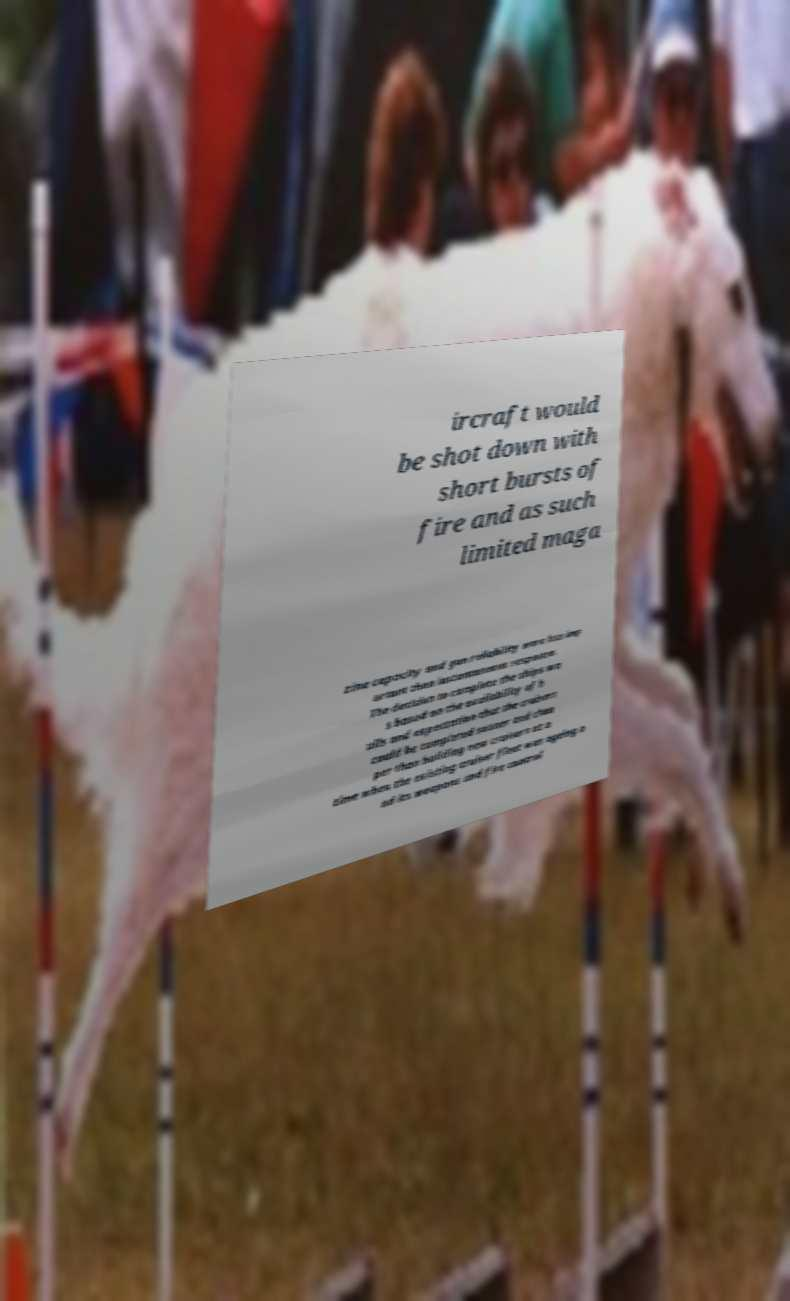For documentation purposes, I need the text within this image transcribed. Could you provide that? ircraft would be shot down with short bursts of fire and as such limited maga zine capacity and gun reliability were less imp ortant than instantaneous response. The decision to complete the ships wa s based on the availability of h ulls and expectation that the cruisers could be completed sooner and chea per than building new cruisers at a time when the existing cruiser fleet was ageing a nd its weapons and fire control 